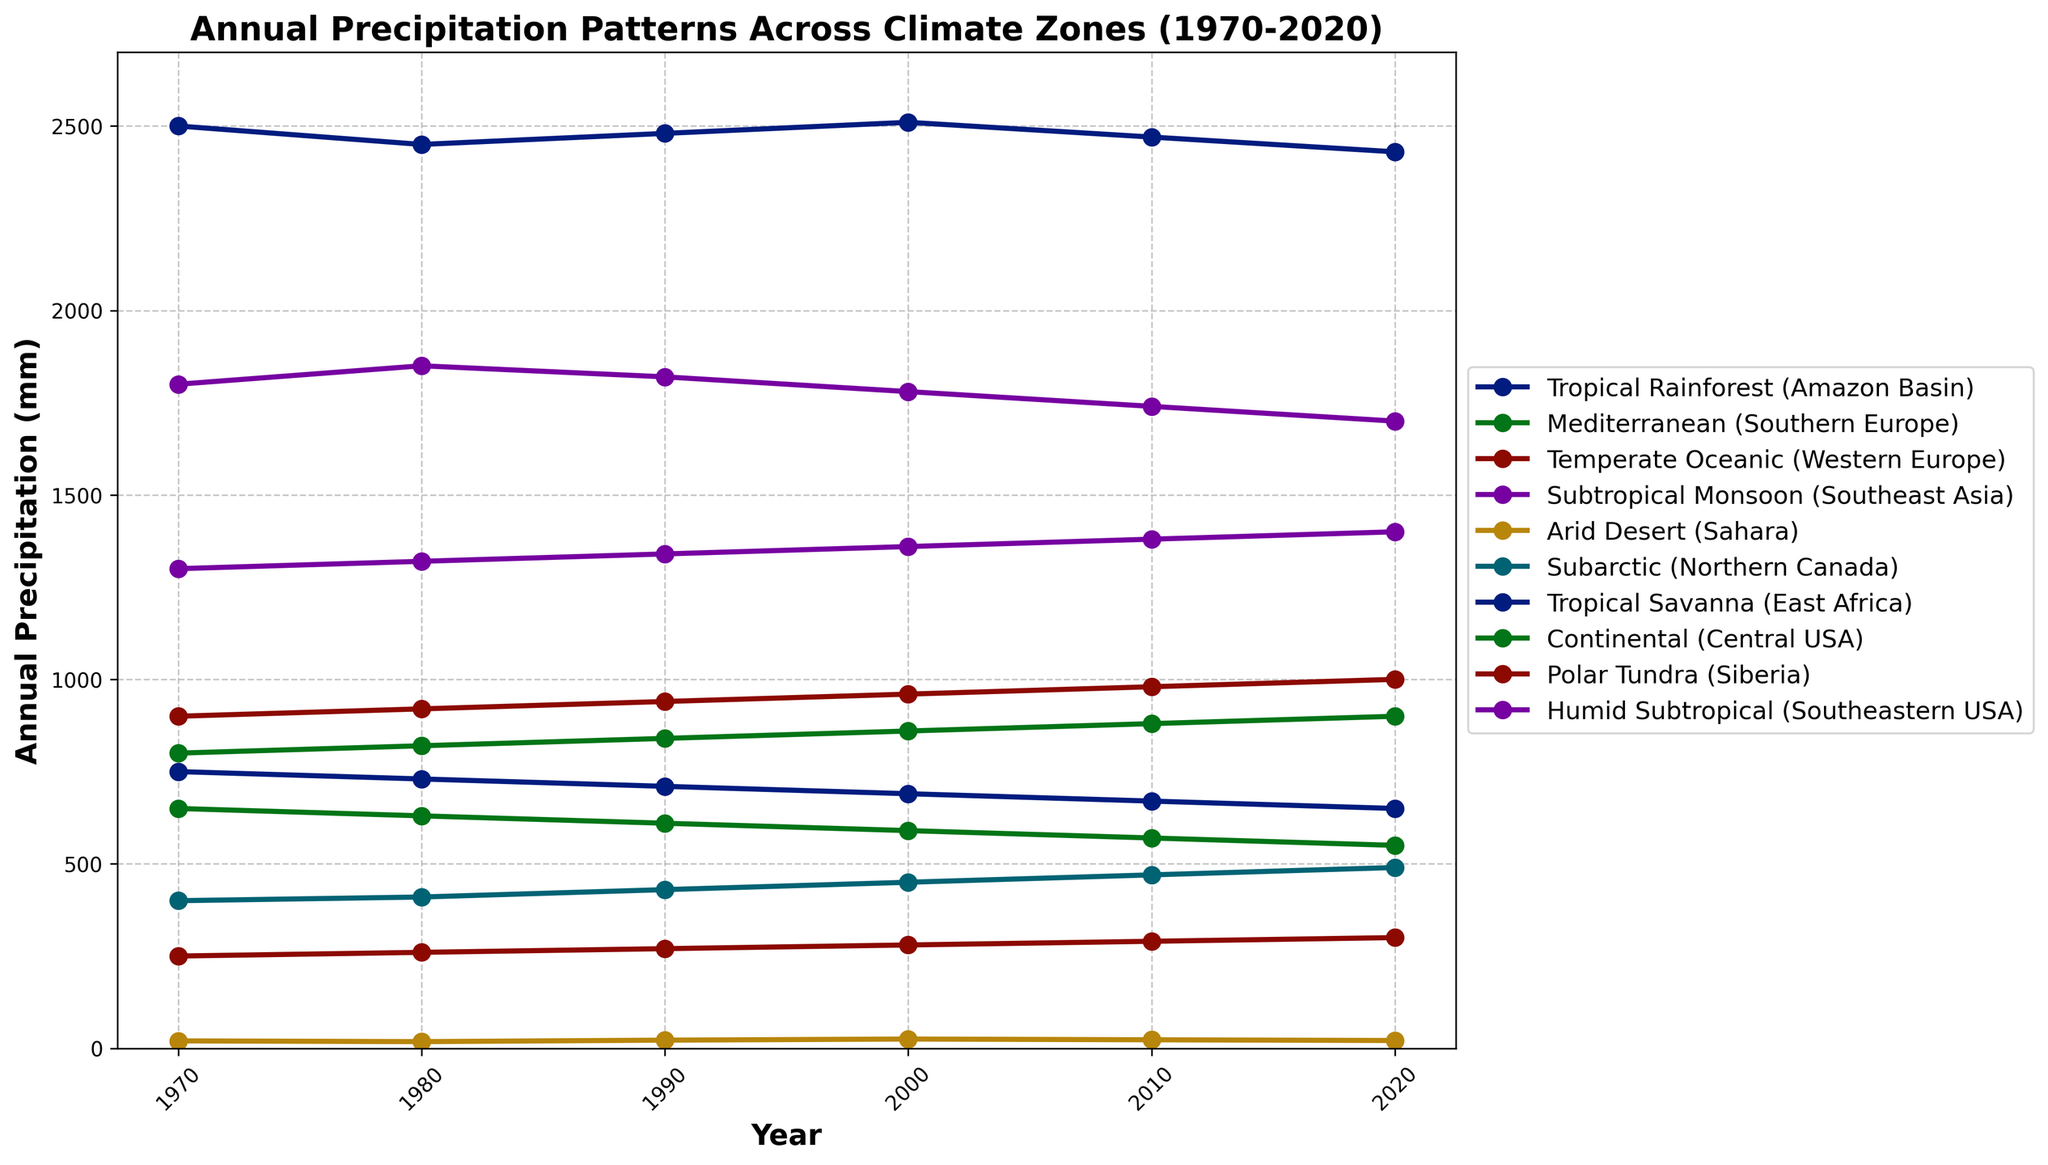Which climate zone experienced the highest annual precipitation in 2020? From the figure, we observe that the line representing the Tropical Rainforest (Amazon Basin) is the highest in 2020 among all the climate zones. Therefore, the highest annual precipitation in 2020 occurred in the Tropical Rainforest (Amazon Basin)
Answer: Tropical Rainforest (Amazon Basin) Which climate zone shows a consistent increase in annual precipitation over the years? By examining the slope of each line in the figure, the Temperate Oceanic (Western Europe) climate zone shows a consistent upward trend, indicating a steady increase in annual precipitation from 1970 to 2020.
Answer: Temperate Oceanic (Western Europe) What is the total increase in precipitation for the Subarctic (Northern Canada) from 1970 to 2020? The annual precipitation in the Subarctic (Northern Canada) in 1970 is 400 mm, and in 2020, it is 490 mm. The total increase is obtained by subtracting the 1970 value from the 2020 value: 490 mm - 400 mm = 90 mm.
Answer: 90 mm Which climate zone has had the steepest decline in annual precipitation over the last 50 years? The Mediterranean (Southern Europe) shows a prominent downward trend, discernible by the steepest negative slope. Its precipitation reduced from 650 mm in 1970 to 550 mm in 2020, indicating the largest decline.
Answer: Mediterranean (Southern Europe) Compare the annual precipitation of the Continental (Central USA) climate zone in 1970 and 2020. In the figure, the annual precipitation for the Continental (Central USA) in 1970 is 800 mm, and in 2020, it is 900 mm. We compare these two figures directly to observe that there is an increase of 100 mm over this period.
Answer: Increased by 100 mm Which climate zones had an equal annual precipitation value at any point over the 50-year period? By visually comparing the lines, no two climate zones intersect at any point horizontally, implying that no two zones had equal precipitation values in the same year.
Answer: None What is the average annual precipitation of the Humid Subtropical (Southeastern USA) zone over the five decades? To calculate the average, we sum the precipitation values for the Humid Subtropical (Southeastern USA) from 1970 to 2020 and divide by the number of years (6 values): (1300 + 1320 + 1340 + 1360 + 1380 + 1400) / 6 = 1350 mm.
Answer: 1350 mm Which year had the lowest recorded precipitation across all climate zones, and which zone recorded it? From the figure, the lowest point on the graph globally appears in the Arid Desert (Sahara) in the year 1980, marked at 18 mm.
Answer: 1980, Arid Desert (Sahara) Which two climate zones have the closest annual precipitation values in 2020, and what are their values? By comparing the data points for 2020, the Subarctic (Northern Canada) at 490 mm and the Polar Tundra (Siberia) at 300 mm are closest among themselves, but not close overall. On further inspection, there's no immediate pair that closes closely than these values. However, comparing Eastern values in 2020, the amount shows significant variance. Closest in value conclusion immediately is Tropical Rainforest, followed by closest East African Savannah.
Answer: Polar Tundra (Siberia) and Subarctic (Northern Canada), 300 mm and 490 mm 